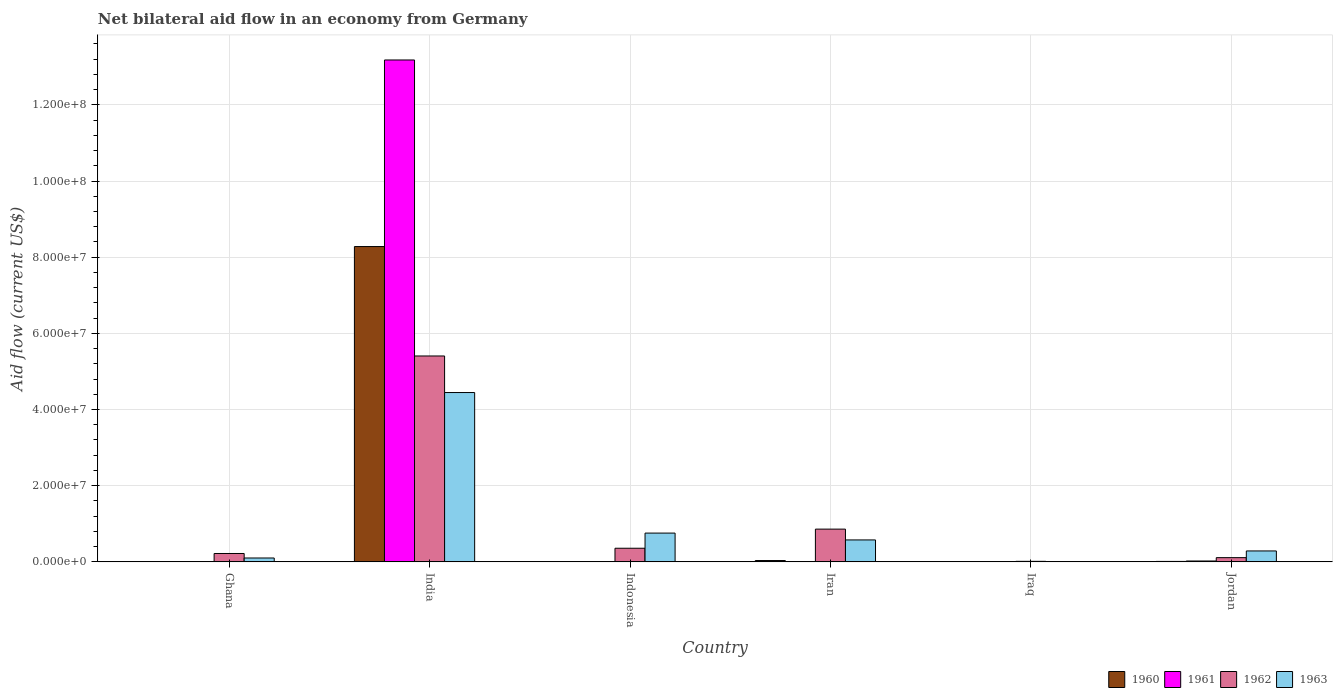How many groups of bars are there?
Your answer should be very brief. 6. Are the number of bars per tick equal to the number of legend labels?
Give a very brief answer. No. How many bars are there on the 4th tick from the left?
Ensure brevity in your answer.  4. What is the label of the 2nd group of bars from the left?
Your response must be concise. India. What is the net bilateral aid flow in 1963 in Indonesia?
Your answer should be compact. 7.56e+06. Across all countries, what is the maximum net bilateral aid flow in 1960?
Your answer should be very brief. 8.28e+07. In which country was the net bilateral aid flow in 1963 maximum?
Your answer should be compact. India. What is the total net bilateral aid flow in 1960 in the graph?
Give a very brief answer. 8.34e+07. What is the difference between the net bilateral aid flow in 1962 in India and that in Indonesia?
Provide a succinct answer. 5.05e+07. What is the difference between the net bilateral aid flow in 1961 in Jordan and the net bilateral aid flow in 1960 in Ghana?
Make the answer very short. 1.80e+05. What is the average net bilateral aid flow in 1961 per country?
Provide a succinct answer. 2.20e+07. What is the difference between the net bilateral aid flow of/in 1963 and net bilateral aid flow of/in 1961 in Ghana?
Your answer should be compact. 9.90e+05. What is the ratio of the net bilateral aid flow in 1963 in Iran to that in Jordan?
Your answer should be compact. 2.01. What is the difference between the highest and the second highest net bilateral aid flow in 1962?
Make the answer very short. 5.05e+07. What is the difference between the highest and the lowest net bilateral aid flow in 1962?
Your response must be concise. 5.39e+07. In how many countries, is the net bilateral aid flow in 1963 greater than the average net bilateral aid flow in 1963 taken over all countries?
Provide a succinct answer. 1. Is the sum of the net bilateral aid flow in 1963 in Ghana and Indonesia greater than the maximum net bilateral aid flow in 1960 across all countries?
Offer a terse response. No. Are all the bars in the graph horizontal?
Your response must be concise. No. How many countries are there in the graph?
Offer a very short reply. 6. What is the difference between two consecutive major ticks on the Y-axis?
Offer a terse response. 2.00e+07. Does the graph contain grids?
Provide a succinct answer. Yes. How many legend labels are there?
Offer a terse response. 4. How are the legend labels stacked?
Make the answer very short. Horizontal. What is the title of the graph?
Your answer should be very brief. Net bilateral aid flow in an economy from Germany. What is the Aid flow (current US$) in 1962 in Ghana?
Give a very brief answer. 2.20e+06. What is the Aid flow (current US$) in 1963 in Ghana?
Your response must be concise. 1.02e+06. What is the Aid flow (current US$) of 1960 in India?
Your answer should be compact. 8.28e+07. What is the Aid flow (current US$) of 1961 in India?
Your answer should be very brief. 1.32e+08. What is the Aid flow (current US$) in 1962 in India?
Your answer should be very brief. 5.41e+07. What is the Aid flow (current US$) of 1963 in India?
Make the answer very short. 4.45e+07. What is the Aid flow (current US$) in 1960 in Indonesia?
Your answer should be very brief. 0. What is the Aid flow (current US$) in 1962 in Indonesia?
Provide a succinct answer. 3.58e+06. What is the Aid flow (current US$) of 1963 in Indonesia?
Your answer should be very brief. 7.56e+06. What is the Aid flow (current US$) in 1961 in Iran?
Ensure brevity in your answer.  3.00e+04. What is the Aid flow (current US$) in 1962 in Iran?
Ensure brevity in your answer.  8.60e+06. What is the Aid flow (current US$) of 1963 in Iran?
Make the answer very short. 5.76e+06. What is the Aid flow (current US$) of 1960 in Iraq?
Ensure brevity in your answer.  6.00e+04. What is the Aid flow (current US$) in 1962 in Iraq?
Make the answer very short. 1.40e+05. What is the Aid flow (current US$) of 1963 in Iraq?
Keep it short and to the point. 9.00e+04. What is the Aid flow (current US$) of 1962 in Jordan?
Offer a very short reply. 1.11e+06. What is the Aid flow (current US$) in 1963 in Jordan?
Provide a succinct answer. 2.87e+06. Across all countries, what is the maximum Aid flow (current US$) of 1960?
Ensure brevity in your answer.  8.28e+07. Across all countries, what is the maximum Aid flow (current US$) in 1961?
Provide a succinct answer. 1.32e+08. Across all countries, what is the maximum Aid flow (current US$) of 1962?
Offer a very short reply. 5.41e+07. Across all countries, what is the maximum Aid flow (current US$) in 1963?
Provide a succinct answer. 4.45e+07. Across all countries, what is the minimum Aid flow (current US$) of 1960?
Make the answer very short. 0. What is the total Aid flow (current US$) in 1960 in the graph?
Keep it short and to the point. 8.34e+07. What is the total Aid flow (current US$) in 1961 in the graph?
Your response must be concise. 1.32e+08. What is the total Aid flow (current US$) in 1962 in the graph?
Your answer should be compact. 6.97e+07. What is the total Aid flow (current US$) in 1963 in the graph?
Make the answer very short. 6.18e+07. What is the difference between the Aid flow (current US$) of 1960 in Ghana and that in India?
Keep it short and to the point. -8.27e+07. What is the difference between the Aid flow (current US$) in 1961 in Ghana and that in India?
Provide a succinct answer. -1.32e+08. What is the difference between the Aid flow (current US$) of 1962 in Ghana and that in India?
Offer a very short reply. -5.19e+07. What is the difference between the Aid flow (current US$) of 1963 in Ghana and that in India?
Provide a short and direct response. -4.34e+07. What is the difference between the Aid flow (current US$) of 1962 in Ghana and that in Indonesia?
Keep it short and to the point. -1.38e+06. What is the difference between the Aid flow (current US$) in 1963 in Ghana and that in Indonesia?
Make the answer very short. -6.54e+06. What is the difference between the Aid flow (current US$) in 1960 in Ghana and that in Iran?
Keep it short and to the point. -3.00e+05. What is the difference between the Aid flow (current US$) of 1962 in Ghana and that in Iran?
Your answer should be compact. -6.40e+06. What is the difference between the Aid flow (current US$) in 1963 in Ghana and that in Iran?
Your response must be concise. -4.74e+06. What is the difference between the Aid flow (current US$) in 1960 in Ghana and that in Iraq?
Offer a very short reply. -10000. What is the difference between the Aid flow (current US$) of 1961 in Ghana and that in Iraq?
Provide a short and direct response. 10000. What is the difference between the Aid flow (current US$) in 1962 in Ghana and that in Iraq?
Make the answer very short. 2.06e+06. What is the difference between the Aid flow (current US$) of 1963 in Ghana and that in Iraq?
Keep it short and to the point. 9.30e+05. What is the difference between the Aid flow (current US$) in 1960 in Ghana and that in Jordan?
Provide a short and direct response. -7.00e+04. What is the difference between the Aid flow (current US$) in 1961 in Ghana and that in Jordan?
Keep it short and to the point. -2.00e+05. What is the difference between the Aid flow (current US$) of 1962 in Ghana and that in Jordan?
Make the answer very short. 1.09e+06. What is the difference between the Aid flow (current US$) in 1963 in Ghana and that in Jordan?
Your response must be concise. -1.85e+06. What is the difference between the Aid flow (current US$) in 1962 in India and that in Indonesia?
Offer a terse response. 5.05e+07. What is the difference between the Aid flow (current US$) in 1963 in India and that in Indonesia?
Make the answer very short. 3.69e+07. What is the difference between the Aid flow (current US$) in 1960 in India and that in Iran?
Keep it short and to the point. 8.24e+07. What is the difference between the Aid flow (current US$) in 1961 in India and that in Iran?
Give a very brief answer. 1.32e+08. What is the difference between the Aid flow (current US$) in 1962 in India and that in Iran?
Your answer should be very brief. 4.55e+07. What is the difference between the Aid flow (current US$) of 1963 in India and that in Iran?
Give a very brief answer. 3.87e+07. What is the difference between the Aid flow (current US$) in 1960 in India and that in Iraq?
Offer a terse response. 8.27e+07. What is the difference between the Aid flow (current US$) of 1961 in India and that in Iraq?
Provide a short and direct response. 1.32e+08. What is the difference between the Aid flow (current US$) of 1962 in India and that in Iraq?
Make the answer very short. 5.39e+07. What is the difference between the Aid flow (current US$) of 1963 in India and that in Iraq?
Make the answer very short. 4.44e+07. What is the difference between the Aid flow (current US$) of 1960 in India and that in Jordan?
Your response must be concise. 8.27e+07. What is the difference between the Aid flow (current US$) in 1961 in India and that in Jordan?
Give a very brief answer. 1.32e+08. What is the difference between the Aid flow (current US$) of 1962 in India and that in Jordan?
Make the answer very short. 5.30e+07. What is the difference between the Aid flow (current US$) in 1963 in India and that in Jordan?
Your answer should be very brief. 4.16e+07. What is the difference between the Aid flow (current US$) of 1962 in Indonesia and that in Iran?
Keep it short and to the point. -5.02e+06. What is the difference between the Aid flow (current US$) of 1963 in Indonesia and that in Iran?
Offer a very short reply. 1.80e+06. What is the difference between the Aid flow (current US$) in 1962 in Indonesia and that in Iraq?
Offer a very short reply. 3.44e+06. What is the difference between the Aid flow (current US$) in 1963 in Indonesia and that in Iraq?
Provide a succinct answer. 7.47e+06. What is the difference between the Aid flow (current US$) in 1962 in Indonesia and that in Jordan?
Provide a succinct answer. 2.47e+06. What is the difference between the Aid flow (current US$) in 1963 in Indonesia and that in Jordan?
Your answer should be compact. 4.69e+06. What is the difference between the Aid flow (current US$) of 1960 in Iran and that in Iraq?
Provide a short and direct response. 2.90e+05. What is the difference between the Aid flow (current US$) in 1961 in Iran and that in Iraq?
Keep it short and to the point. 10000. What is the difference between the Aid flow (current US$) in 1962 in Iran and that in Iraq?
Provide a short and direct response. 8.46e+06. What is the difference between the Aid flow (current US$) in 1963 in Iran and that in Iraq?
Your answer should be very brief. 5.67e+06. What is the difference between the Aid flow (current US$) in 1960 in Iran and that in Jordan?
Provide a succinct answer. 2.30e+05. What is the difference between the Aid flow (current US$) of 1961 in Iran and that in Jordan?
Keep it short and to the point. -2.00e+05. What is the difference between the Aid flow (current US$) in 1962 in Iran and that in Jordan?
Ensure brevity in your answer.  7.49e+06. What is the difference between the Aid flow (current US$) in 1963 in Iran and that in Jordan?
Your answer should be compact. 2.89e+06. What is the difference between the Aid flow (current US$) in 1961 in Iraq and that in Jordan?
Your response must be concise. -2.10e+05. What is the difference between the Aid flow (current US$) in 1962 in Iraq and that in Jordan?
Offer a terse response. -9.70e+05. What is the difference between the Aid flow (current US$) of 1963 in Iraq and that in Jordan?
Your answer should be very brief. -2.78e+06. What is the difference between the Aid flow (current US$) in 1960 in Ghana and the Aid flow (current US$) in 1961 in India?
Your response must be concise. -1.32e+08. What is the difference between the Aid flow (current US$) of 1960 in Ghana and the Aid flow (current US$) of 1962 in India?
Offer a very short reply. -5.40e+07. What is the difference between the Aid flow (current US$) of 1960 in Ghana and the Aid flow (current US$) of 1963 in India?
Your answer should be compact. -4.44e+07. What is the difference between the Aid flow (current US$) in 1961 in Ghana and the Aid flow (current US$) in 1962 in India?
Your answer should be very brief. -5.40e+07. What is the difference between the Aid flow (current US$) in 1961 in Ghana and the Aid flow (current US$) in 1963 in India?
Offer a very short reply. -4.44e+07. What is the difference between the Aid flow (current US$) in 1962 in Ghana and the Aid flow (current US$) in 1963 in India?
Provide a succinct answer. -4.23e+07. What is the difference between the Aid flow (current US$) of 1960 in Ghana and the Aid flow (current US$) of 1962 in Indonesia?
Keep it short and to the point. -3.53e+06. What is the difference between the Aid flow (current US$) in 1960 in Ghana and the Aid flow (current US$) in 1963 in Indonesia?
Ensure brevity in your answer.  -7.51e+06. What is the difference between the Aid flow (current US$) in 1961 in Ghana and the Aid flow (current US$) in 1962 in Indonesia?
Keep it short and to the point. -3.55e+06. What is the difference between the Aid flow (current US$) of 1961 in Ghana and the Aid flow (current US$) of 1963 in Indonesia?
Give a very brief answer. -7.53e+06. What is the difference between the Aid flow (current US$) in 1962 in Ghana and the Aid flow (current US$) in 1963 in Indonesia?
Ensure brevity in your answer.  -5.36e+06. What is the difference between the Aid flow (current US$) of 1960 in Ghana and the Aid flow (current US$) of 1962 in Iran?
Provide a succinct answer. -8.55e+06. What is the difference between the Aid flow (current US$) in 1960 in Ghana and the Aid flow (current US$) in 1963 in Iran?
Offer a very short reply. -5.71e+06. What is the difference between the Aid flow (current US$) in 1961 in Ghana and the Aid flow (current US$) in 1962 in Iran?
Make the answer very short. -8.57e+06. What is the difference between the Aid flow (current US$) in 1961 in Ghana and the Aid flow (current US$) in 1963 in Iran?
Make the answer very short. -5.73e+06. What is the difference between the Aid flow (current US$) in 1962 in Ghana and the Aid flow (current US$) in 1963 in Iran?
Give a very brief answer. -3.56e+06. What is the difference between the Aid flow (current US$) in 1960 in Ghana and the Aid flow (current US$) in 1961 in Iraq?
Offer a terse response. 3.00e+04. What is the difference between the Aid flow (current US$) of 1960 in Ghana and the Aid flow (current US$) of 1962 in Iraq?
Give a very brief answer. -9.00e+04. What is the difference between the Aid flow (current US$) in 1961 in Ghana and the Aid flow (current US$) in 1962 in Iraq?
Make the answer very short. -1.10e+05. What is the difference between the Aid flow (current US$) in 1961 in Ghana and the Aid flow (current US$) in 1963 in Iraq?
Provide a succinct answer. -6.00e+04. What is the difference between the Aid flow (current US$) of 1962 in Ghana and the Aid flow (current US$) of 1963 in Iraq?
Give a very brief answer. 2.11e+06. What is the difference between the Aid flow (current US$) of 1960 in Ghana and the Aid flow (current US$) of 1962 in Jordan?
Your response must be concise. -1.06e+06. What is the difference between the Aid flow (current US$) of 1960 in Ghana and the Aid flow (current US$) of 1963 in Jordan?
Your answer should be compact. -2.82e+06. What is the difference between the Aid flow (current US$) of 1961 in Ghana and the Aid flow (current US$) of 1962 in Jordan?
Your answer should be very brief. -1.08e+06. What is the difference between the Aid flow (current US$) in 1961 in Ghana and the Aid flow (current US$) in 1963 in Jordan?
Your response must be concise. -2.84e+06. What is the difference between the Aid flow (current US$) of 1962 in Ghana and the Aid flow (current US$) of 1963 in Jordan?
Give a very brief answer. -6.70e+05. What is the difference between the Aid flow (current US$) of 1960 in India and the Aid flow (current US$) of 1962 in Indonesia?
Give a very brief answer. 7.92e+07. What is the difference between the Aid flow (current US$) in 1960 in India and the Aid flow (current US$) in 1963 in Indonesia?
Give a very brief answer. 7.52e+07. What is the difference between the Aid flow (current US$) of 1961 in India and the Aid flow (current US$) of 1962 in Indonesia?
Keep it short and to the point. 1.28e+08. What is the difference between the Aid flow (current US$) of 1961 in India and the Aid flow (current US$) of 1963 in Indonesia?
Your answer should be compact. 1.24e+08. What is the difference between the Aid flow (current US$) of 1962 in India and the Aid flow (current US$) of 1963 in Indonesia?
Provide a succinct answer. 4.65e+07. What is the difference between the Aid flow (current US$) of 1960 in India and the Aid flow (current US$) of 1961 in Iran?
Your answer should be compact. 8.28e+07. What is the difference between the Aid flow (current US$) in 1960 in India and the Aid flow (current US$) in 1962 in Iran?
Make the answer very short. 7.42e+07. What is the difference between the Aid flow (current US$) in 1960 in India and the Aid flow (current US$) in 1963 in Iran?
Your answer should be very brief. 7.70e+07. What is the difference between the Aid flow (current US$) in 1961 in India and the Aid flow (current US$) in 1962 in Iran?
Your answer should be very brief. 1.23e+08. What is the difference between the Aid flow (current US$) in 1961 in India and the Aid flow (current US$) in 1963 in Iran?
Keep it short and to the point. 1.26e+08. What is the difference between the Aid flow (current US$) of 1962 in India and the Aid flow (current US$) of 1963 in Iran?
Give a very brief answer. 4.83e+07. What is the difference between the Aid flow (current US$) in 1960 in India and the Aid flow (current US$) in 1961 in Iraq?
Your response must be concise. 8.28e+07. What is the difference between the Aid flow (current US$) in 1960 in India and the Aid flow (current US$) in 1962 in Iraq?
Your answer should be compact. 8.26e+07. What is the difference between the Aid flow (current US$) in 1960 in India and the Aid flow (current US$) in 1963 in Iraq?
Your response must be concise. 8.27e+07. What is the difference between the Aid flow (current US$) of 1961 in India and the Aid flow (current US$) of 1962 in Iraq?
Your answer should be very brief. 1.32e+08. What is the difference between the Aid flow (current US$) in 1961 in India and the Aid flow (current US$) in 1963 in Iraq?
Your answer should be compact. 1.32e+08. What is the difference between the Aid flow (current US$) of 1962 in India and the Aid flow (current US$) of 1963 in Iraq?
Your answer should be very brief. 5.40e+07. What is the difference between the Aid flow (current US$) of 1960 in India and the Aid flow (current US$) of 1961 in Jordan?
Offer a very short reply. 8.26e+07. What is the difference between the Aid flow (current US$) of 1960 in India and the Aid flow (current US$) of 1962 in Jordan?
Offer a very short reply. 8.17e+07. What is the difference between the Aid flow (current US$) in 1960 in India and the Aid flow (current US$) in 1963 in Jordan?
Provide a short and direct response. 7.99e+07. What is the difference between the Aid flow (current US$) in 1961 in India and the Aid flow (current US$) in 1962 in Jordan?
Give a very brief answer. 1.31e+08. What is the difference between the Aid flow (current US$) of 1961 in India and the Aid flow (current US$) of 1963 in Jordan?
Offer a terse response. 1.29e+08. What is the difference between the Aid flow (current US$) of 1962 in India and the Aid flow (current US$) of 1963 in Jordan?
Make the answer very short. 5.12e+07. What is the difference between the Aid flow (current US$) of 1962 in Indonesia and the Aid flow (current US$) of 1963 in Iran?
Your answer should be compact. -2.18e+06. What is the difference between the Aid flow (current US$) in 1962 in Indonesia and the Aid flow (current US$) in 1963 in Iraq?
Your answer should be very brief. 3.49e+06. What is the difference between the Aid flow (current US$) of 1962 in Indonesia and the Aid flow (current US$) of 1963 in Jordan?
Your answer should be compact. 7.10e+05. What is the difference between the Aid flow (current US$) of 1960 in Iran and the Aid flow (current US$) of 1961 in Iraq?
Give a very brief answer. 3.30e+05. What is the difference between the Aid flow (current US$) of 1961 in Iran and the Aid flow (current US$) of 1962 in Iraq?
Your answer should be very brief. -1.10e+05. What is the difference between the Aid flow (current US$) of 1962 in Iran and the Aid flow (current US$) of 1963 in Iraq?
Provide a succinct answer. 8.51e+06. What is the difference between the Aid flow (current US$) in 1960 in Iran and the Aid flow (current US$) in 1962 in Jordan?
Your answer should be compact. -7.60e+05. What is the difference between the Aid flow (current US$) of 1960 in Iran and the Aid flow (current US$) of 1963 in Jordan?
Keep it short and to the point. -2.52e+06. What is the difference between the Aid flow (current US$) of 1961 in Iran and the Aid flow (current US$) of 1962 in Jordan?
Keep it short and to the point. -1.08e+06. What is the difference between the Aid flow (current US$) in 1961 in Iran and the Aid flow (current US$) in 1963 in Jordan?
Your response must be concise. -2.84e+06. What is the difference between the Aid flow (current US$) of 1962 in Iran and the Aid flow (current US$) of 1963 in Jordan?
Provide a succinct answer. 5.73e+06. What is the difference between the Aid flow (current US$) of 1960 in Iraq and the Aid flow (current US$) of 1961 in Jordan?
Offer a very short reply. -1.70e+05. What is the difference between the Aid flow (current US$) of 1960 in Iraq and the Aid flow (current US$) of 1962 in Jordan?
Your answer should be very brief. -1.05e+06. What is the difference between the Aid flow (current US$) in 1960 in Iraq and the Aid flow (current US$) in 1963 in Jordan?
Give a very brief answer. -2.81e+06. What is the difference between the Aid flow (current US$) in 1961 in Iraq and the Aid flow (current US$) in 1962 in Jordan?
Provide a succinct answer. -1.09e+06. What is the difference between the Aid flow (current US$) in 1961 in Iraq and the Aid flow (current US$) in 1963 in Jordan?
Keep it short and to the point. -2.85e+06. What is the difference between the Aid flow (current US$) in 1962 in Iraq and the Aid flow (current US$) in 1963 in Jordan?
Provide a short and direct response. -2.73e+06. What is the average Aid flow (current US$) of 1960 per country?
Offer a very short reply. 1.39e+07. What is the average Aid flow (current US$) of 1961 per country?
Your answer should be very brief. 2.20e+07. What is the average Aid flow (current US$) of 1962 per country?
Your response must be concise. 1.16e+07. What is the average Aid flow (current US$) in 1963 per country?
Offer a very short reply. 1.03e+07. What is the difference between the Aid flow (current US$) in 1960 and Aid flow (current US$) in 1961 in Ghana?
Give a very brief answer. 2.00e+04. What is the difference between the Aid flow (current US$) of 1960 and Aid flow (current US$) of 1962 in Ghana?
Offer a very short reply. -2.15e+06. What is the difference between the Aid flow (current US$) in 1960 and Aid flow (current US$) in 1963 in Ghana?
Your answer should be very brief. -9.70e+05. What is the difference between the Aid flow (current US$) of 1961 and Aid flow (current US$) of 1962 in Ghana?
Ensure brevity in your answer.  -2.17e+06. What is the difference between the Aid flow (current US$) of 1961 and Aid flow (current US$) of 1963 in Ghana?
Your response must be concise. -9.90e+05. What is the difference between the Aid flow (current US$) of 1962 and Aid flow (current US$) of 1963 in Ghana?
Your answer should be compact. 1.18e+06. What is the difference between the Aid flow (current US$) of 1960 and Aid flow (current US$) of 1961 in India?
Offer a terse response. -4.90e+07. What is the difference between the Aid flow (current US$) in 1960 and Aid flow (current US$) in 1962 in India?
Give a very brief answer. 2.87e+07. What is the difference between the Aid flow (current US$) in 1960 and Aid flow (current US$) in 1963 in India?
Provide a succinct answer. 3.83e+07. What is the difference between the Aid flow (current US$) in 1961 and Aid flow (current US$) in 1962 in India?
Make the answer very short. 7.77e+07. What is the difference between the Aid flow (current US$) in 1961 and Aid flow (current US$) in 1963 in India?
Give a very brief answer. 8.73e+07. What is the difference between the Aid flow (current US$) of 1962 and Aid flow (current US$) of 1963 in India?
Your answer should be compact. 9.60e+06. What is the difference between the Aid flow (current US$) in 1962 and Aid flow (current US$) in 1963 in Indonesia?
Make the answer very short. -3.98e+06. What is the difference between the Aid flow (current US$) of 1960 and Aid flow (current US$) of 1962 in Iran?
Keep it short and to the point. -8.25e+06. What is the difference between the Aid flow (current US$) of 1960 and Aid flow (current US$) of 1963 in Iran?
Offer a very short reply. -5.41e+06. What is the difference between the Aid flow (current US$) in 1961 and Aid flow (current US$) in 1962 in Iran?
Your response must be concise. -8.57e+06. What is the difference between the Aid flow (current US$) of 1961 and Aid flow (current US$) of 1963 in Iran?
Provide a succinct answer. -5.73e+06. What is the difference between the Aid flow (current US$) in 1962 and Aid flow (current US$) in 1963 in Iran?
Provide a short and direct response. 2.84e+06. What is the difference between the Aid flow (current US$) of 1960 and Aid flow (current US$) of 1962 in Iraq?
Ensure brevity in your answer.  -8.00e+04. What is the difference between the Aid flow (current US$) of 1960 and Aid flow (current US$) of 1963 in Iraq?
Your answer should be very brief. -3.00e+04. What is the difference between the Aid flow (current US$) of 1961 and Aid flow (current US$) of 1962 in Iraq?
Your answer should be compact. -1.20e+05. What is the difference between the Aid flow (current US$) in 1961 and Aid flow (current US$) in 1963 in Iraq?
Offer a terse response. -7.00e+04. What is the difference between the Aid flow (current US$) of 1960 and Aid flow (current US$) of 1961 in Jordan?
Ensure brevity in your answer.  -1.10e+05. What is the difference between the Aid flow (current US$) of 1960 and Aid flow (current US$) of 1962 in Jordan?
Ensure brevity in your answer.  -9.90e+05. What is the difference between the Aid flow (current US$) in 1960 and Aid flow (current US$) in 1963 in Jordan?
Your response must be concise. -2.75e+06. What is the difference between the Aid flow (current US$) of 1961 and Aid flow (current US$) of 1962 in Jordan?
Offer a terse response. -8.80e+05. What is the difference between the Aid flow (current US$) of 1961 and Aid flow (current US$) of 1963 in Jordan?
Your answer should be very brief. -2.64e+06. What is the difference between the Aid flow (current US$) in 1962 and Aid flow (current US$) in 1963 in Jordan?
Offer a very short reply. -1.76e+06. What is the ratio of the Aid flow (current US$) in 1960 in Ghana to that in India?
Your answer should be very brief. 0. What is the ratio of the Aid flow (current US$) in 1962 in Ghana to that in India?
Provide a succinct answer. 0.04. What is the ratio of the Aid flow (current US$) in 1963 in Ghana to that in India?
Ensure brevity in your answer.  0.02. What is the ratio of the Aid flow (current US$) in 1962 in Ghana to that in Indonesia?
Offer a very short reply. 0.61. What is the ratio of the Aid flow (current US$) of 1963 in Ghana to that in Indonesia?
Make the answer very short. 0.13. What is the ratio of the Aid flow (current US$) in 1960 in Ghana to that in Iran?
Offer a terse response. 0.14. What is the ratio of the Aid flow (current US$) of 1961 in Ghana to that in Iran?
Give a very brief answer. 1. What is the ratio of the Aid flow (current US$) of 1962 in Ghana to that in Iran?
Offer a very short reply. 0.26. What is the ratio of the Aid flow (current US$) of 1963 in Ghana to that in Iran?
Ensure brevity in your answer.  0.18. What is the ratio of the Aid flow (current US$) of 1960 in Ghana to that in Iraq?
Give a very brief answer. 0.83. What is the ratio of the Aid flow (current US$) of 1961 in Ghana to that in Iraq?
Your answer should be compact. 1.5. What is the ratio of the Aid flow (current US$) of 1962 in Ghana to that in Iraq?
Provide a succinct answer. 15.71. What is the ratio of the Aid flow (current US$) of 1963 in Ghana to that in Iraq?
Keep it short and to the point. 11.33. What is the ratio of the Aid flow (current US$) of 1960 in Ghana to that in Jordan?
Ensure brevity in your answer.  0.42. What is the ratio of the Aid flow (current US$) of 1961 in Ghana to that in Jordan?
Offer a very short reply. 0.13. What is the ratio of the Aid flow (current US$) in 1962 in Ghana to that in Jordan?
Your response must be concise. 1.98. What is the ratio of the Aid flow (current US$) in 1963 in Ghana to that in Jordan?
Offer a terse response. 0.36. What is the ratio of the Aid flow (current US$) of 1962 in India to that in Indonesia?
Your answer should be compact. 15.1. What is the ratio of the Aid flow (current US$) in 1963 in India to that in Indonesia?
Ensure brevity in your answer.  5.88. What is the ratio of the Aid flow (current US$) of 1960 in India to that in Iran?
Offer a very short reply. 236.54. What is the ratio of the Aid flow (current US$) of 1961 in India to that in Iran?
Provide a short and direct response. 4392.67. What is the ratio of the Aid flow (current US$) in 1962 in India to that in Iran?
Ensure brevity in your answer.  6.29. What is the ratio of the Aid flow (current US$) in 1963 in India to that in Iran?
Your response must be concise. 7.72. What is the ratio of the Aid flow (current US$) of 1960 in India to that in Iraq?
Offer a very short reply. 1379.83. What is the ratio of the Aid flow (current US$) of 1961 in India to that in Iraq?
Your answer should be very brief. 6589. What is the ratio of the Aid flow (current US$) in 1962 in India to that in Iraq?
Ensure brevity in your answer.  386.14. What is the ratio of the Aid flow (current US$) of 1963 in India to that in Iraq?
Offer a very short reply. 494. What is the ratio of the Aid flow (current US$) in 1960 in India to that in Jordan?
Your answer should be compact. 689.92. What is the ratio of the Aid flow (current US$) of 1961 in India to that in Jordan?
Give a very brief answer. 572.96. What is the ratio of the Aid flow (current US$) in 1962 in India to that in Jordan?
Your response must be concise. 48.7. What is the ratio of the Aid flow (current US$) of 1963 in India to that in Jordan?
Keep it short and to the point. 15.49. What is the ratio of the Aid flow (current US$) in 1962 in Indonesia to that in Iran?
Your response must be concise. 0.42. What is the ratio of the Aid flow (current US$) in 1963 in Indonesia to that in Iran?
Offer a terse response. 1.31. What is the ratio of the Aid flow (current US$) of 1962 in Indonesia to that in Iraq?
Ensure brevity in your answer.  25.57. What is the ratio of the Aid flow (current US$) in 1962 in Indonesia to that in Jordan?
Offer a very short reply. 3.23. What is the ratio of the Aid flow (current US$) in 1963 in Indonesia to that in Jordan?
Provide a short and direct response. 2.63. What is the ratio of the Aid flow (current US$) in 1960 in Iran to that in Iraq?
Give a very brief answer. 5.83. What is the ratio of the Aid flow (current US$) of 1961 in Iran to that in Iraq?
Provide a short and direct response. 1.5. What is the ratio of the Aid flow (current US$) in 1962 in Iran to that in Iraq?
Give a very brief answer. 61.43. What is the ratio of the Aid flow (current US$) in 1963 in Iran to that in Iraq?
Your answer should be very brief. 64. What is the ratio of the Aid flow (current US$) of 1960 in Iran to that in Jordan?
Your answer should be very brief. 2.92. What is the ratio of the Aid flow (current US$) in 1961 in Iran to that in Jordan?
Give a very brief answer. 0.13. What is the ratio of the Aid flow (current US$) of 1962 in Iran to that in Jordan?
Give a very brief answer. 7.75. What is the ratio of the Aid flow (current US$) of 1963 in Iran to that in Jordan?
Offer a terse response. 2.01. What is the ratio of the Aid flow (current US$) of 1961 in Iraq to that in Jordan?
Your answer should be compact. 0.09. What is the ratio of the Aid flow (current US$) of 1962 in Iraq to that in Jordan?
Provide a succinct answer. 0.13. What is the ratio of the Aid flow (current US$) in 1963 in Iraq to that in Jordan?
Give a very brief answer. 0.03. What is the difference between the highest and the second highest Aid flow (current US$) in 1960?
Your answer should be compact. 8.24e+07. What is the difference between the highest and the second highest Aid flow (current US$) in 1961?
Provide a succinct answer. 1.32e+08. What is the difference between the highest and the second highest Aid flow (current US$) of 1962?
Provide a short and direct response. 4.55e+07. What is the difference between the highest and the second highest Aid flow (current US$) of 1963?
Offer a terse response. 3.69e+07. What is the difference between the highest and the lowest Aid flow (current US$) in 1960?
Offer a terse response. 8.28e+07. What is the difference between the highest and the lowest Aid flow (current US$) in 1961?
Make the answer very short. 1.32e+08. What is the difference between the highest and the lowest Aid flow (current US$) of 1962?
Keep it short and to the point. 5.39e+07. What is the difference between the highest and the lowest Aid flow (current US$) in 1963?
Offer a terse response. 4.44e+07. 